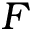Convert formula to latex. <formula><loc_0><loc_0><loc_500><loc_500>F</formula> 